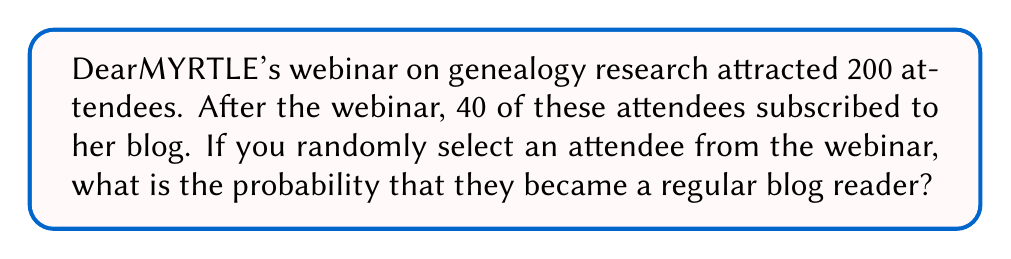Solve this math problem. To solve this problem, we need to use the concept of probability as the ratio of favorable outcomes to total possible outcomes.

Step 1: Identify the total number of attendees (total possible outcomes).
Total attendees = 200

Step 2: Identify the number of attendees who became regular blog readers (favorable outcomes).
Blog subscribers = 40

Step 3: Calculate the probability using the formula:
$$ P(\text{becoming a regular blog reader}) = \frac{\text{number of blog subscribers}}{\text{total number of attendees}} $$

$$ P(\text{becoming a regular blog reader}) = \frac{40}{200} $$

Step 4: Simplify the fraction:
$$ P(\text{becoming a regular blog reader}) = \frac{40}{200} = \frac{1}{5} = 0.2 $$

Therefore, the probability of a randomly selected webinar attendee becoming a regular blog reader is $\frac{1}{5}$ or 0.2 or 20%.
Answer: $\frac{1}{5}$ or 0.2 